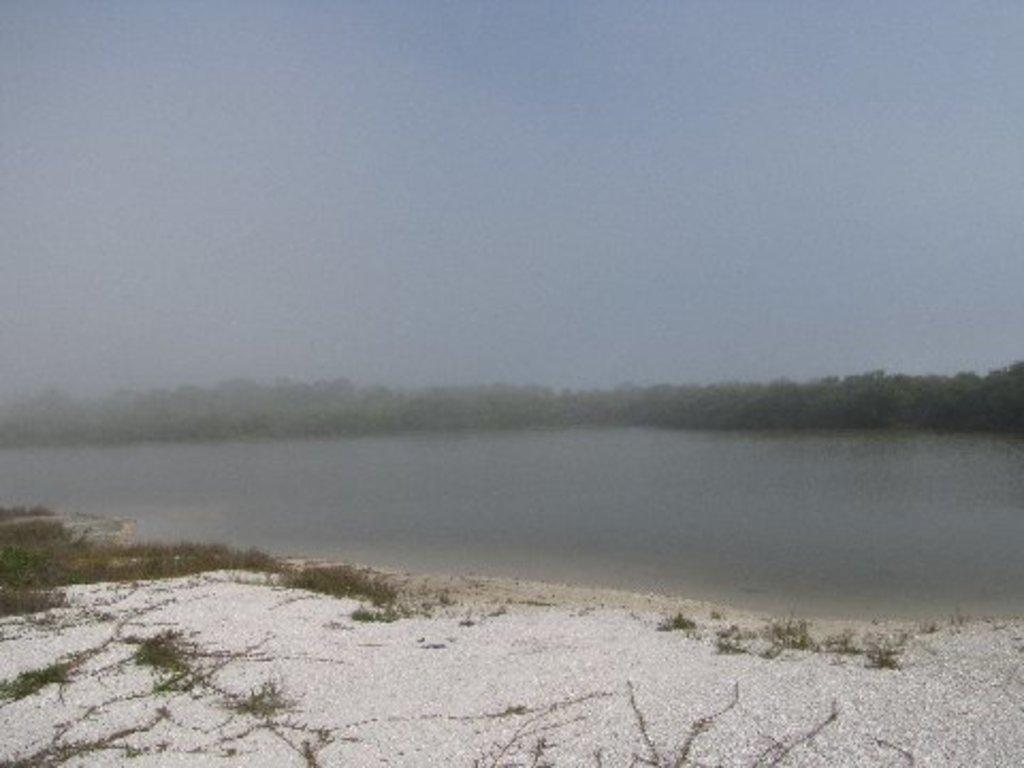What is in the foreground of the image? There is sand in the foreground of the image. What type of vegetation is on the left side of the image? There is grass on the left side of the image. What can be seen in the background of the image? There is water and trees visible in the background of the image. What is visible in the sky in the image? The sky is visible in the image, and it contains clouds. What type of lip can be seen on the canvas in the image? There is no lip or canvas present in the image. How many stamps are visible on the sand in the image? There are no stamps visible on the sand in the image. 